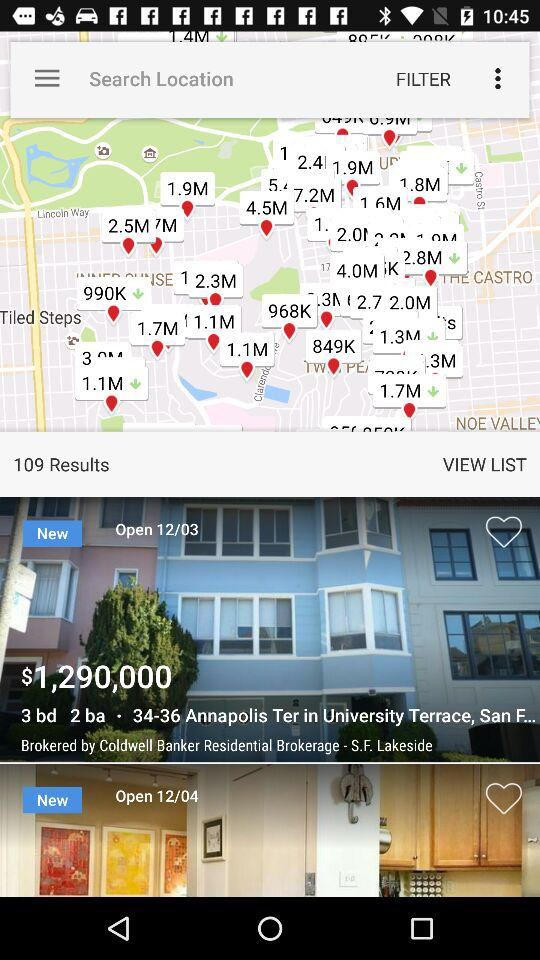How many properties are currently open?
Answer the question using a single word or phrase. 2 